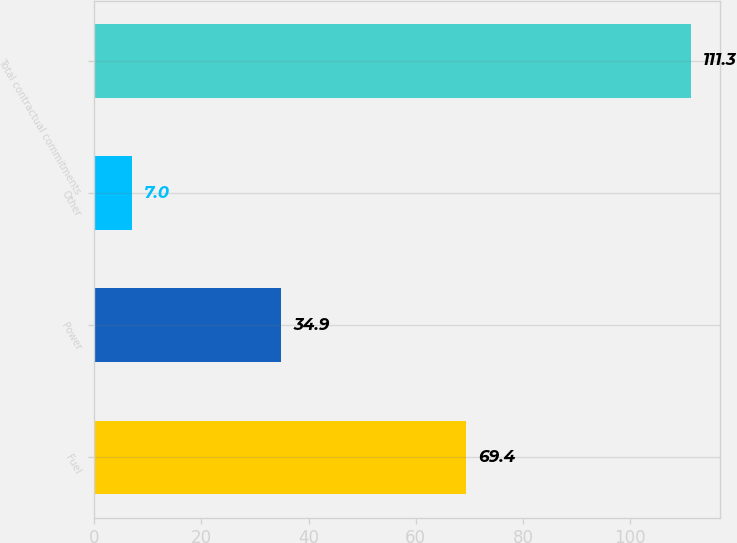<chart> <loc_0><loc_0><loc_500><loc_500><bar_chart><fcel>Fuel<fcel>Power<fcel>Other<fcel>Total contractual commitments<nl><fcel>69.4<fcel>34.9<fcel>7<fcel>111.3<nl></chart> 